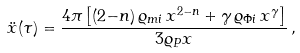Convert formula to latex. <formula><loc_0><loc_0><loc_500><loc_500>\ddot { x } ( \tau ) = \frac { 4 \pi \left [ ( 2 { - } n ) \, \varrho _ { m i } \, x ^ { 2 - n } + \gamma \, \varrho _ { \Phi i } \, x ^ { \gamma } \right ] } { 3 \varrho _ { P } x } \, ,</formula> 